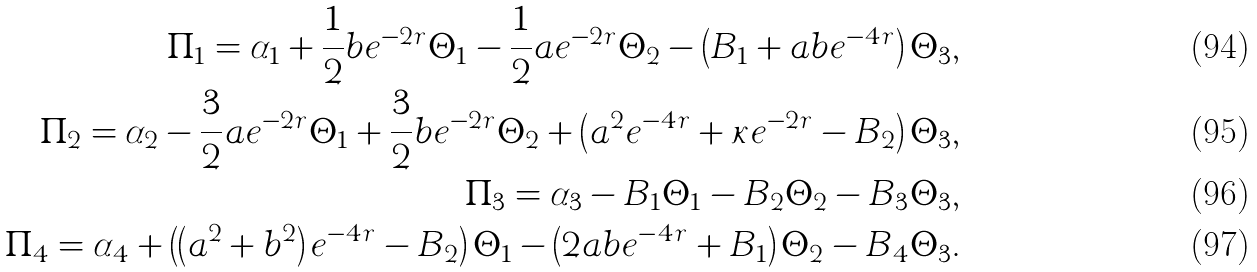Convert formula to latex. <formula><loc_0><loc_0><loc_500><loc_500>\Pi _ { 1 } = \alpha _ { 1 } + \frac { 1 } { 2 } b e ^ { - 2 r } \Theta _ { 1 } - \frac { 1 } { 2 } a e ^ { - 2 r } \Theta _ { 2 } - \left ( B _ { 1 } + a b e ^ { - 4 r } \right ) \Theta _ { 3 } , \\ \Pi _ { 2 } = \alpha _ { 2 } - \frac { 3 } { 2 } a e ^ { - 2 r } \Theta _ { 1 } + \frac { 3 } { 2 } b e ^ { - 2 r } \Theta _ { 2 } + \left ( a ^ { 2 } e ^ { - 4 r } + \kappa e ^ { - 2 r } - B _ { 2 } \right ) \Theta _ { 3 } , \\ \Pi _ { 3 } = \alpha _ { 3 } - B _ { 1 } \Theta _ { 1 } - B _ { 2 } \Theta _ { 2 } - B _ { 3 } \Theta _ { 3 } , \\ \Pi _ { 4 } = \alpha _ { 4 } + \left ( \left ( a ^ { 2 } + b ^ { 2 } \right ) e ^ { - 4 r } - B _ { 2 } \right ) \Theta _ { 1 } - \left ( 2 a b e ^ { - 4 r } + B _ { 1 } \right ) \Theta _ { 2 } - B _ { 4 } \Theta _ { 3 } .</formula> 